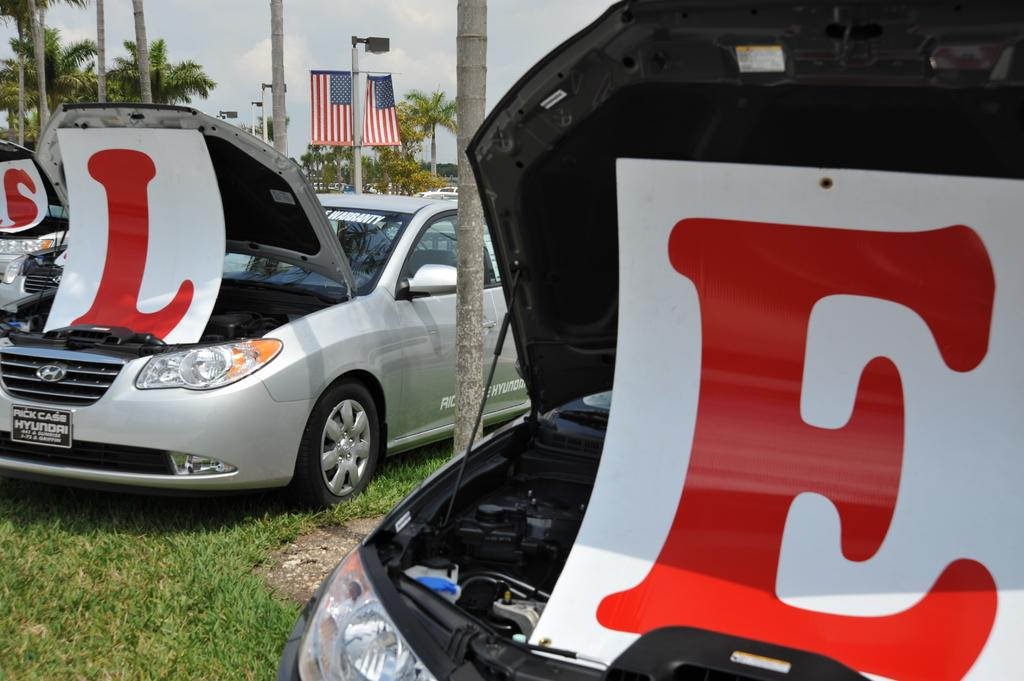What type of vehicles can be seen in the image? There are cars on the grass in the image. What other objects can be seen in the image besides the cars? There are letter boards, flags, trees, light poles, and some unspecified objects in the image. What can be used to display messages or information in the image? Letter boards can be used to display messages or information in the image. What is visible in the background of the image? The sky is visible in the background of the image. Can you tell me how many dogs are playing with the flags in the image? There are no dogs present in the image; it features cars on the grass, letter boards, flags, trees, light poles, and unspecified objects. What is the chance of winning a prize in the image? There is no indication of a prize or any chance of winning in the image. 